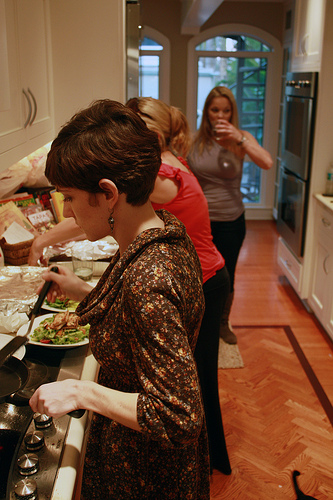Imagine this kitchen is in a futuristic setting. How would you describe it? In the futuristic kitchen, advanced technology seamlessly blends with modern design. The countertops are intelligent surfaces that can display recipes, weigh ingredients, and even suggest meal plans. Holographic projections replace traditional cookbooks and screens, offering interactive guidance. The stove operates with induction cooking on sleek, temperature-responsive surfaces, and the double oven can proficiently multi-task with AI-driven precision and energy-efficient cooking modes. The lighting adjusts automatically for optimal visibility, and the voice-activated assistants help manage kitchen tasks effortlessly. The kitchen floor still maintains an elegant design, possibly rendered with smart materials that adapt in color and warmth, enhancing the overall futuristic aesthetic. 